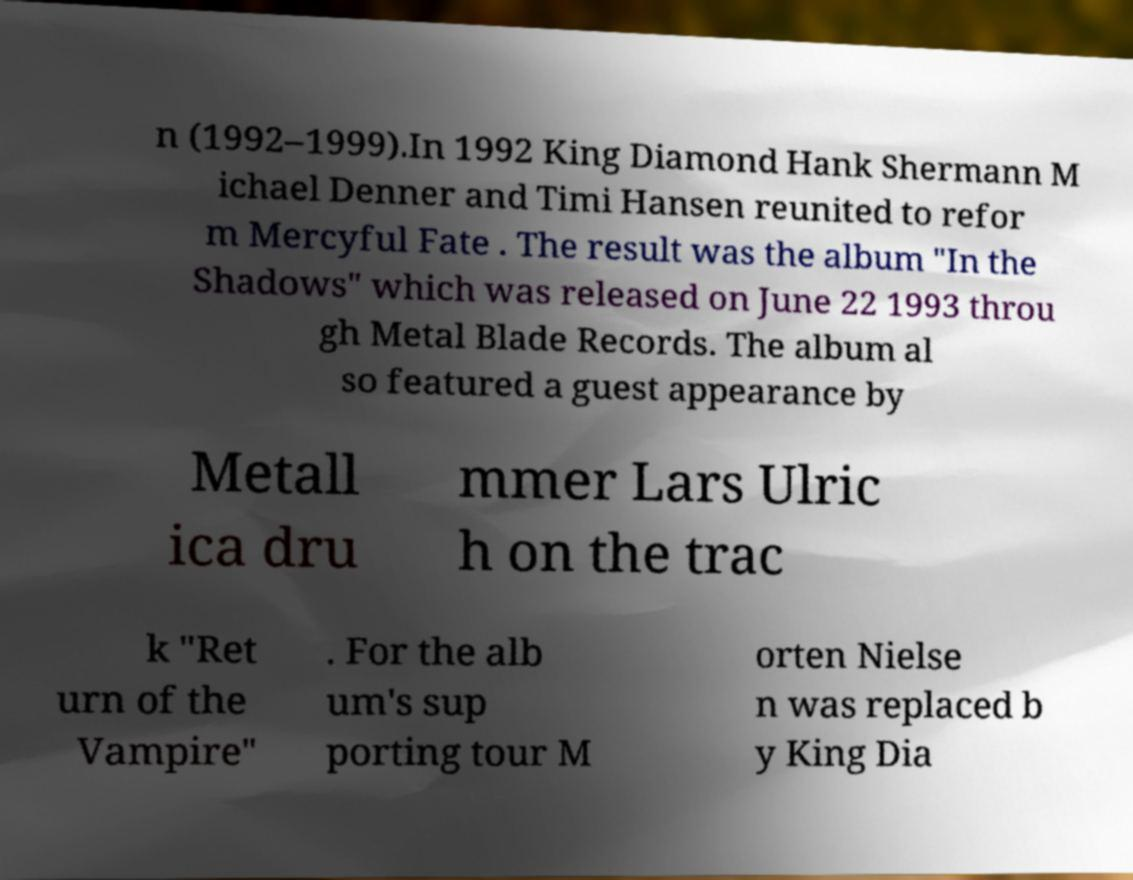For documentation purposes, I need the text within this image transcribed. Could you provide that? n (1992–1999).In 1992 King Diamond Hank Shermann M ichael Denner and Timi Hansen reunited to refor m Mercyful Fate . The result was the album "In the Shadows" which was released on June 22 1993 throu gh Metal Blade Records. The album al so featured a guest appearance by Metall ica dru mmer Lars Ulric h on the trac k "Ret urn of the Vampire" . For the alb um's sup porting tour M orten Nielse n was replaced b y King Dia 